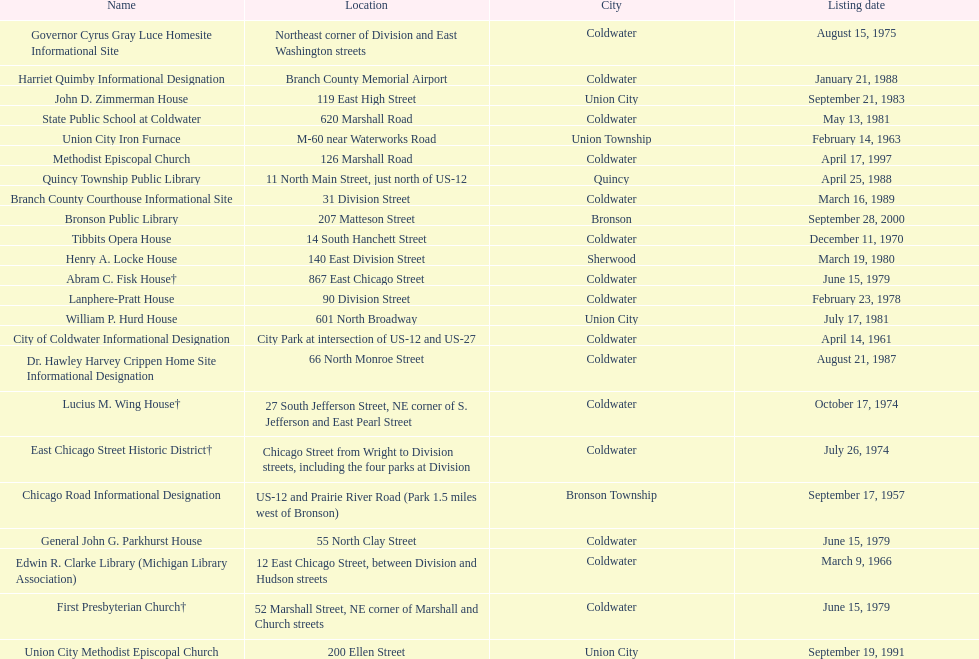Which site was listed earlier, the state public school or the edwin r. clarke library? Edwin R. Clarke Library. 